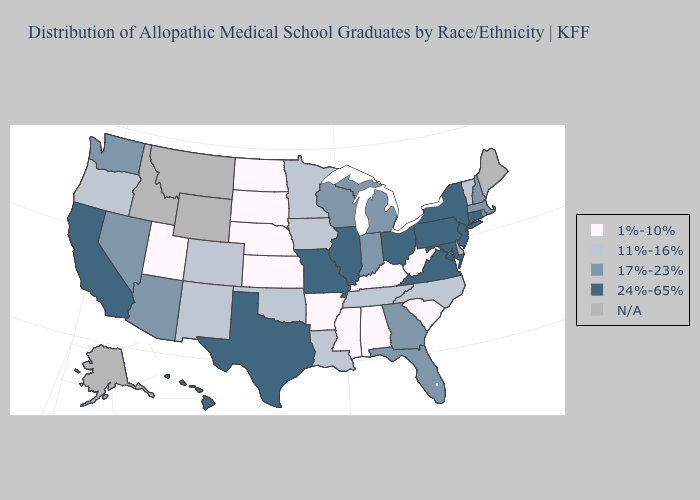Name the states that have a value in the range 1%-10%?
Be succinct. Alabama, Arkansas, Kansas, Kentucky, Mississippi, Nebraska, North Dakota, South Carolina, South Dakota, Utah, West Virginia. Among the states that border Virginia , which have the highest value?
Give a very brief answer. Maryland. Does the first symbol in the legend represent the smallest category?
Give a very brief answer. Yes. Does Massachusetts have the highest value in the Northeast?
Be succinct. No. What is the highest value in the USA?
Give a very brief answer. 24%-65%. What is the value of New York?
Write a very short answer. 24%-65%. Name the states that have a value in the range N/A?
Quick response, please. Alaska, Delaware, Idaho, Maine, Montana, Wyoming. Does the map have missing data?
Answer briefly. Yes. How many symbols are there in the legend?
Write a very short answer. 5. Name the states that have a value in the range 1%-10%?
Short answer required. Alabama, Arkansas, Kansas, Kentucky, Mississippi, Nebraska, North Dakota, South Carolina, South Dakota, Utah, West Virginia. Does Illinois have the highest value in the MidWest?
Write a very short answer. Yes. Name the states that have a value in the range 11%-16%?
Keep it brief. Colorado, Iowa, Louisiana, Minnesota, New Mexico, North Carolina, Oklahoma, Oregon, Tennessee, Vermont. Among the states that border Kansas , which have the lowest value?
Quick response, please. Nebraska. Name the states that have a value in the range 1%-10%?
Short answer required. Alabama, Arkansas, Kansas, Kentucky, Mississippi, Nebraska, North Dakota, South Carolina, South Dakota, Utah, West Virginia. 